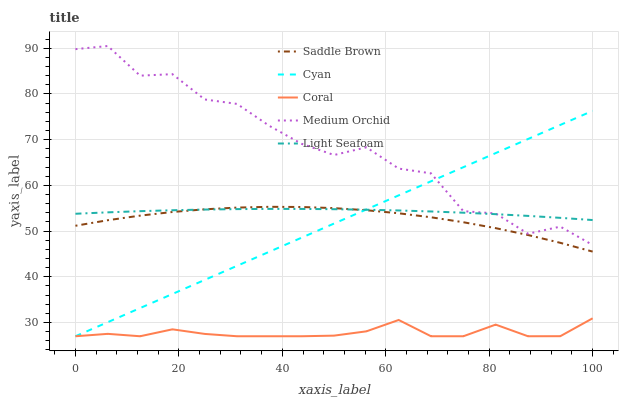Does Coral have the minimum area under the curve?
Answer yes or no. Yes. Does Medium Orchid have the maximum area under the curve?
Answer yes or no. Yes. Does Medium Orchid have the minimum area under the curve?
Answer yes or no. No. Does Coral have the maximum area under the curve?
Answer yes or no. No. Is Cyan the smoothest?
Answer yes or no. Yes. Is Medium Orchid the roughest?
Answer yes or no. Yes. Is Coral the smoothest?
Answer yes or no. No. Is Coral the roughest?
Answer yes or no. No. Does Cyan have the lowest value?
Answer yes or no. Yes. Does Medium Orchid have the lowest value?
Answer yes or no. No. Does Medium Orchid have the highest value?
Answer yes or no. Yes. Does Coral have the highest value?
Answer yes or no. No. Is Coral less than Saddle Brown?
Answer yes or no. Yes. Is Light Seafoam greater than Coral?
Answer yes or no. Yes. Does Cyan intersect Light Seafoam?
Answer yes or no. Yes. Is Cyan less than Light Seafoam?
Answer yes or no. No. Is Cyan greater than Light Seafoam?
Answer yes or no. No. Does Coral intersect Saddle Brown?
Answer yes or no. No. 